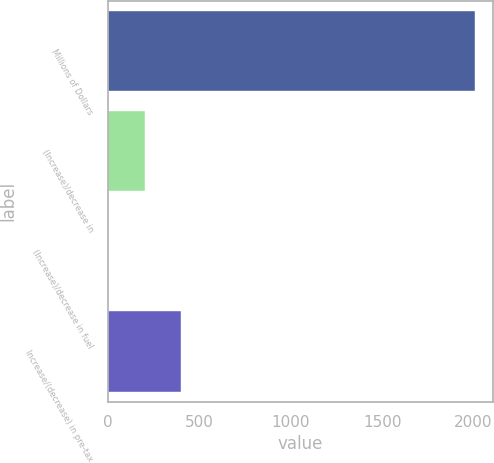Convert chart. <chart><loc_0><loc_0><loc_500><loc_500><bar_chart><fcel>Millions of Dollars<fcel>(Increase)/decrease in<fcel>(Increase)/decrease in fuel<fcel>Increase/(decrease) in pre-tax<nl><fcel>2007<fcel>201.6<fcel>1<fcel>402.2<nl></chart> 